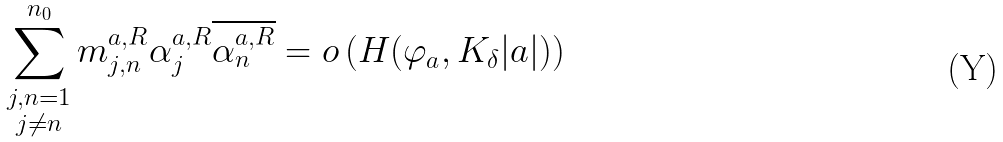Convert formula to latex. <formula><loc_0><loc_0><loc_500><loc_500>\sum _ { \substack { j , n = 1 \\ j \neq n } } ^ { n _ { 0 } } m _ { j , n } ^ { a , R } \alpha _ { j } ^ { a , R } \overline { \alpha _ { n } ^ { a , R } } = o \left ( H ( \varphi _ { a } , K _ { \delta } | a | ) \right )</formula> 